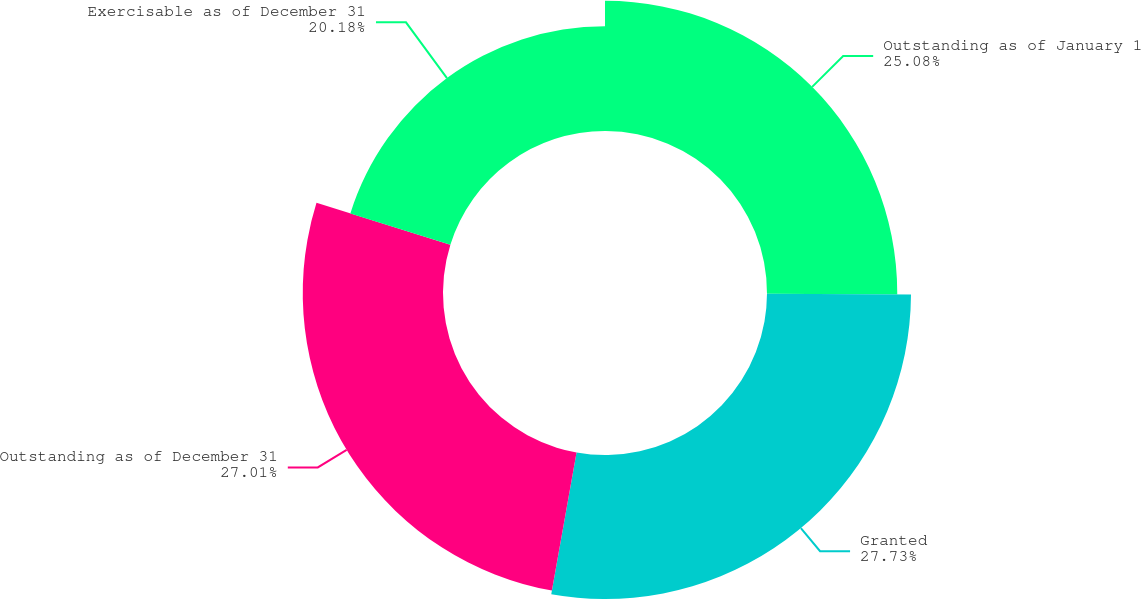<chart> <loc_0><loc_0><loc_500><loc_500><pie_chart><fcel>Outstanding as of January 1<fcel>Granted<fcel>Outstanding as of December 31<fcel>Exercisable as of December 31<nl><fcel>25.08%<fcel>27.73%<fcel>27.01%<fcel>20.18%<nl></chart> 